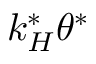Convert formula to latex. <formula><loc_0><loc_0><loc_500><loc_500>k _ { H } ^ { * } \theta ^ { * }</formula> 